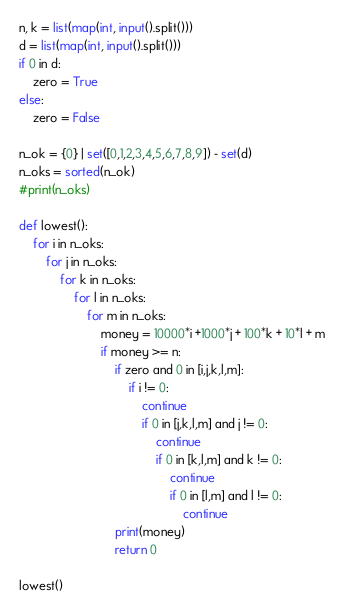Convert code to text. <code><loc_0><loc_0><loc_500><loc_500><_Python_>n, k = list(map(int, input().split()))
d = list(map(int, input().split()))
if 0 in d:
    zero = True
else:
    zero = False

n_ok = {0} | set([0,1,2,3,4,5,6,7,8,9]) - set(d)
n_oks = sorted(n_ok)
#print(n_oks)

def lowest():
    for i in n_oks:
        for j in n_oks:
            for k in n_oks:
                for l in n_oks:
                    for m in n_oks:
                        money = 10000*i +1000*j + 100*k + 10*l + m
                        if money >= n:
                            if zero and 0 in [i,j,k,l,m]:
                                if i != 0:
                                    continue
                                    if 0 in [j,k,l,m] and j != 0:
                                        continue
                                        if 0 in [k,l,m] and k != 0:
                                            continue
                                            if 0 in [l,m] and l != 0:
                                                continue
                            print(money)
                            return 0

lowest()</code> 